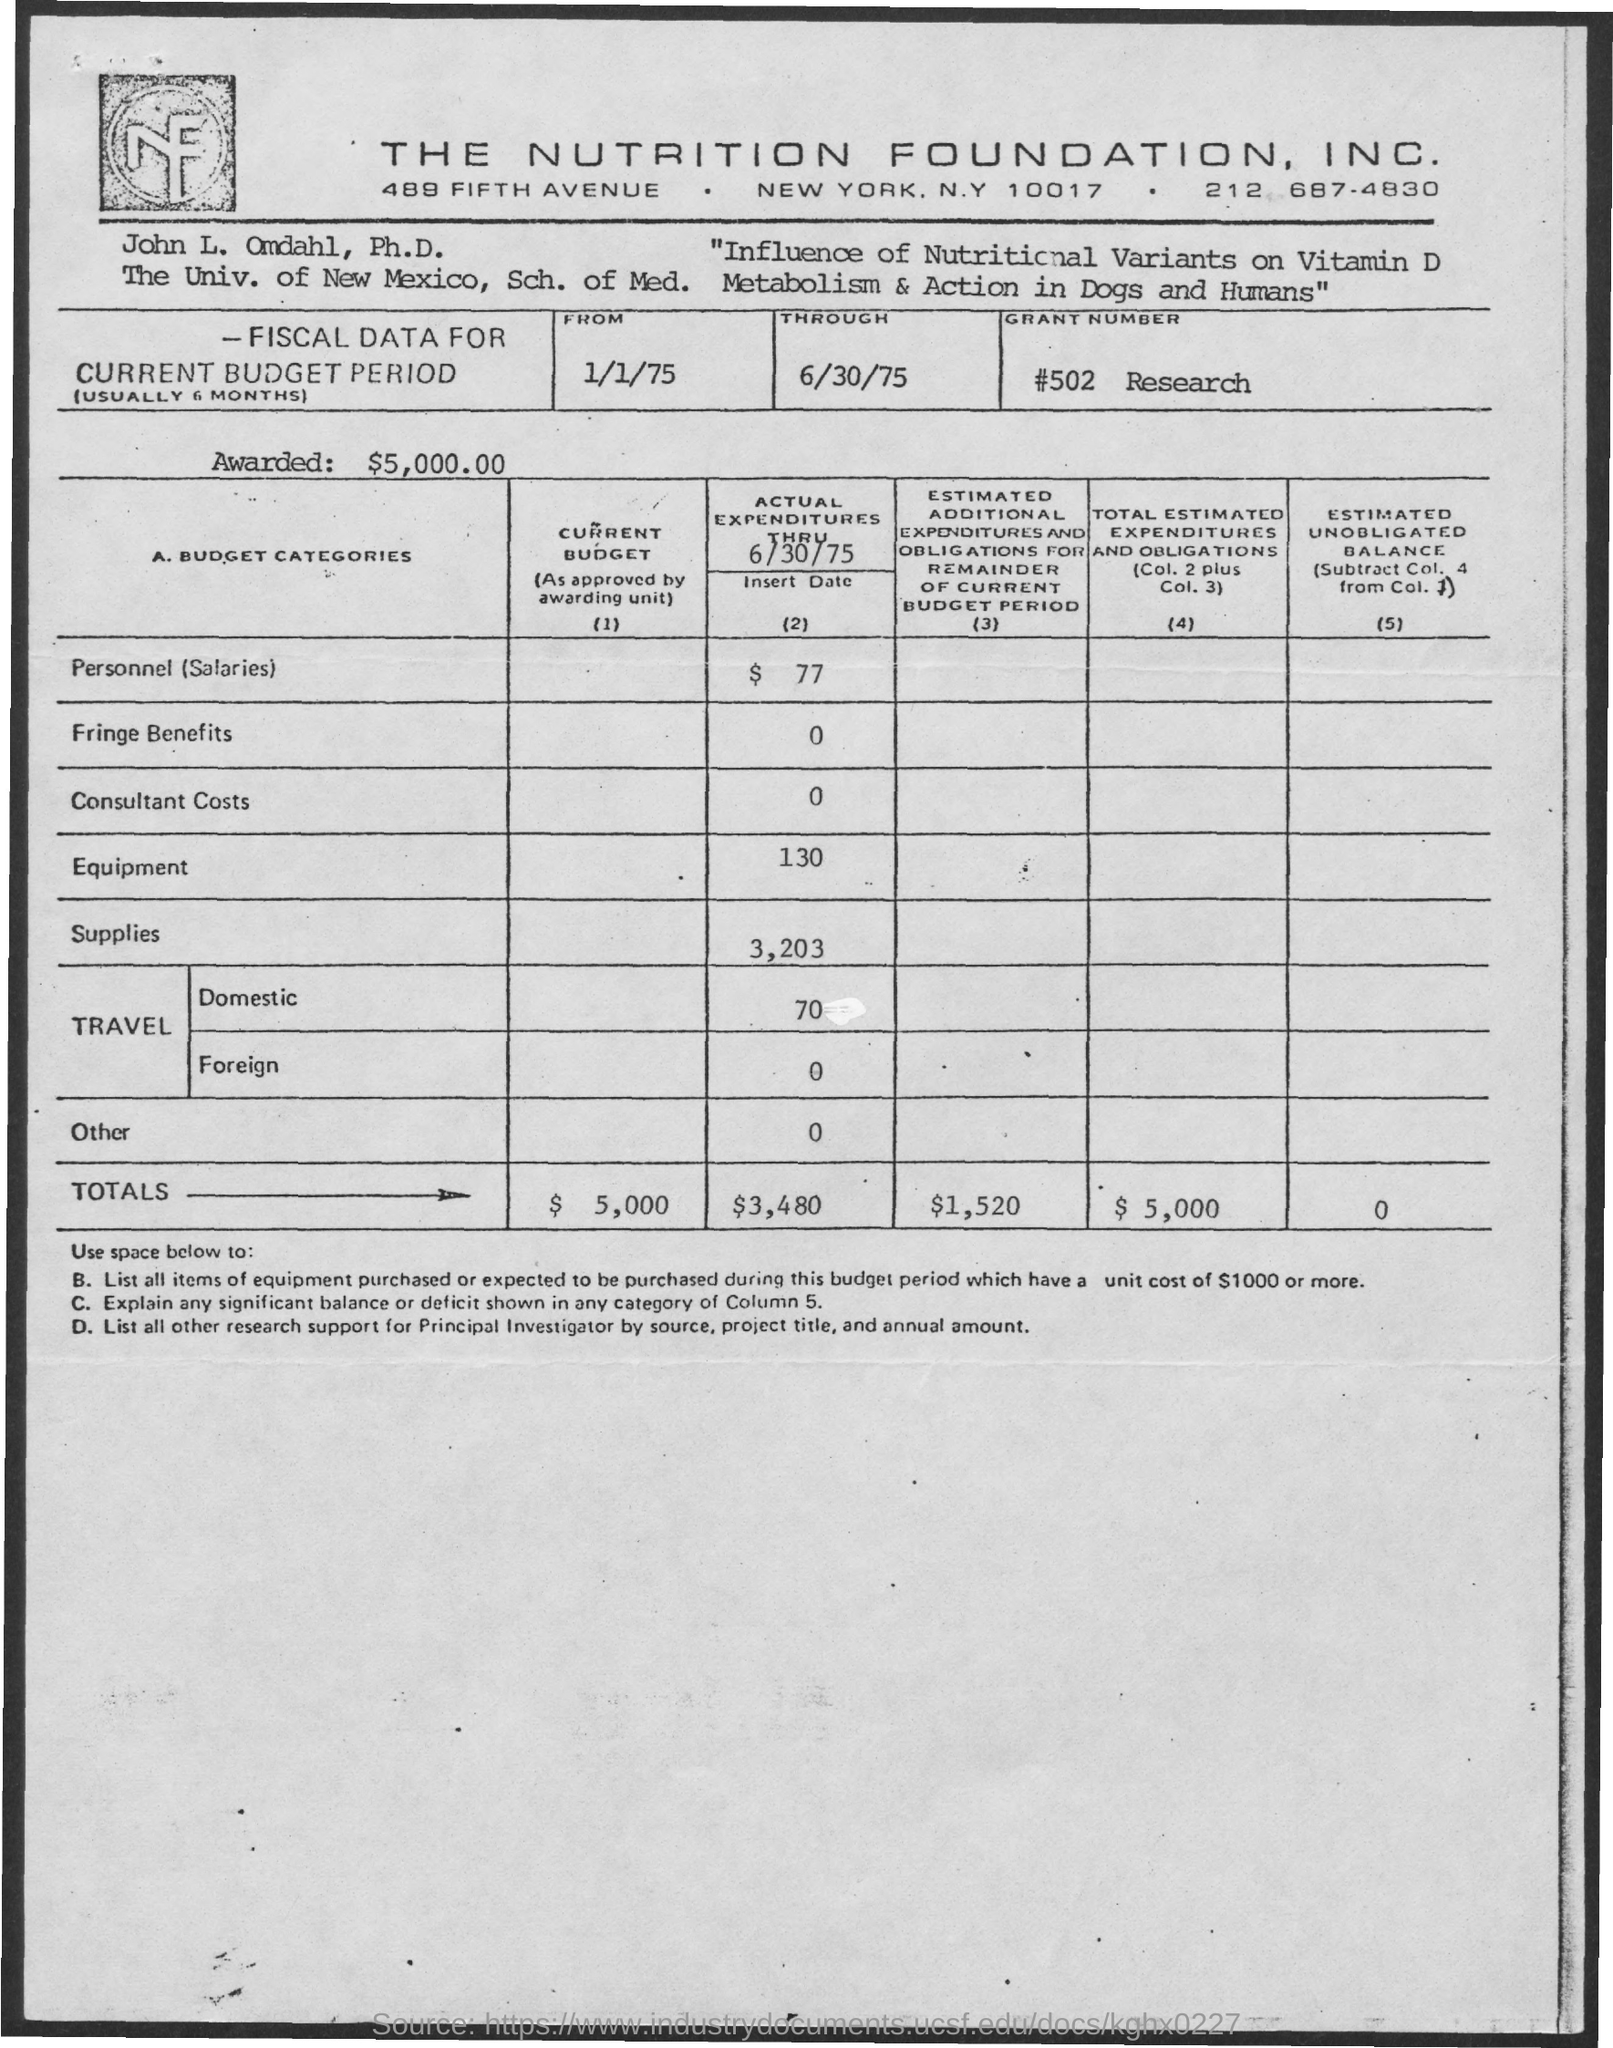What is the Grant Number?
Make the answer very short. #502 Research. What is the Current Budget Period from?
Give a very brief answer. 1/1/75. What is the Current Budget Period through?
Give a very brief answer. 6/30/75. What are the Totals for Current Budget?
Make the answer very short. 5,000. What is the Actual Expenditures thru 6/30/75 for Personnel (Salaries)?
Ensure brevity in your answer.  77. What is the Actual Expenditures thru 6/30/75 for Fringe Benefits?
Make the answer very short. $ 0. What is the Actual Expenditures thru 6/30/75 for Consultant Costs?
Offer a very short reply. 0. What is the Actual Expenditures thru 6/30/75 for Equipment?
Keep it short and to the point. 130. What is the Actual Expenditures thru 6/30/75 for Supplies?
Your answer should be very brief. 3,203. 